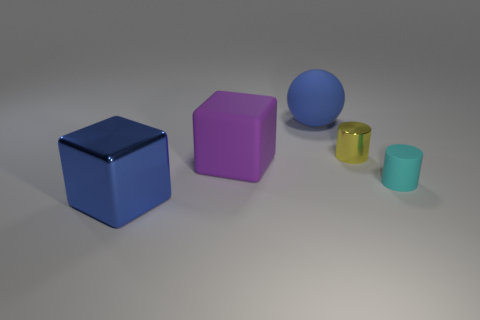Is there anything else that is the same color as the small matte thing?
Give a very brief answer. No. The small cylinder that is in front of the tiny object behind the small matte object is made of what material?
Ensure brevity in your answer.  Rubber. Are the tiny yellow thing and the blue object that is behind the big purple object made of the same material?
Make the answer very short. No. What number of things are either tiny cylinders that are on the left side of the tiny rubber cylinder or big green rubber things?
Provide a short and direct response. 1. Is there a small metallic object that has the same color as the large matte ball?
Your response must be concise. No. Is the shape of the cyan thing the same as the small thing behind the small matte object?
Your answer should be compact. Yes. How many things are both behind the tiny metallic object and in front of the small cyan object?
Provide a short and direct response. 0. There is another object that is the same shape as the small cyan matte thing; what material is it?
Give a very brief answer. Metal. What is the size of the rubber object in front of the large cube to the right of the big blue metal block?
Offer a very short reply. Small. Are there any rubber blocks?
Ensure brevity in your answer.  Yes. 